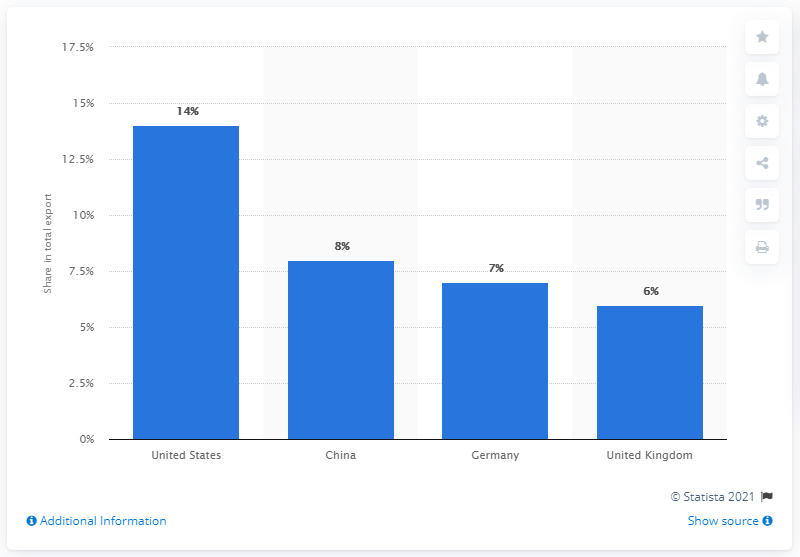Identify some key points in this picture. In 2019, the United States was Pakistan's most important export partner. In 2019, the United States was Pakistan's most significant export partner. 